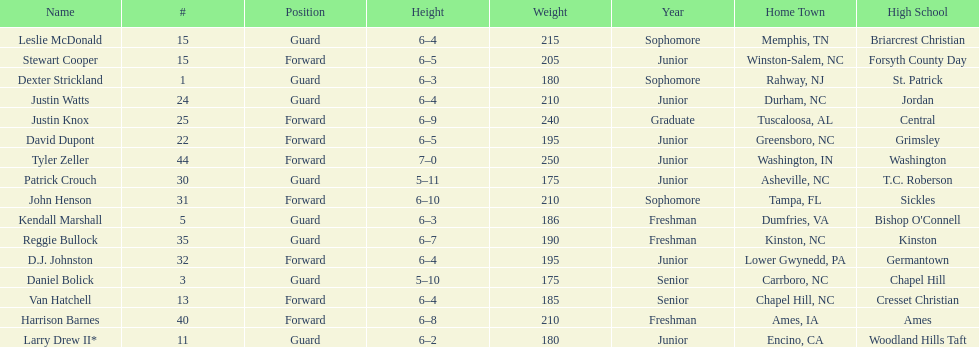How many players were taller than van hatchell? 7. 